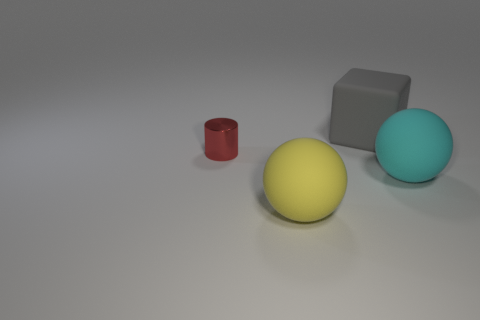Is the number of matte balls less than the number of cubes? no 